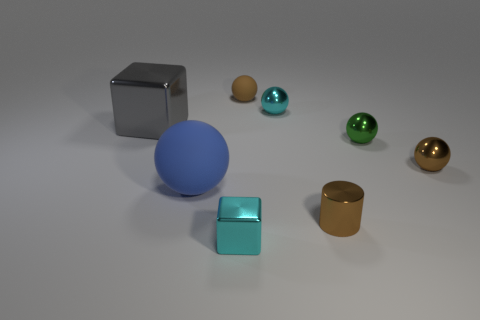Subtract 2 spheres. How many spheres are left? 3 Subtract all tiny green spheres. How many spheres are left? 4 Subtract all blue balls. How many balls are left? 4 Subtract all purple spheres. Subtract all purple cylinders. How many spheres are left? 5 Add 2 tiny blocks. How many objects exist? 10 Subtract all cylinders. How many objects are left? 7 Add 8 large gray things. How many large gray things are left? 9 Add 1 brown matte things. How many brown matte things exist? 2 Subtract 0 yellow spheres. How many objects are left? 8 Subtract all green objects. Subtract all blue spheres. How many objects are left? 6 